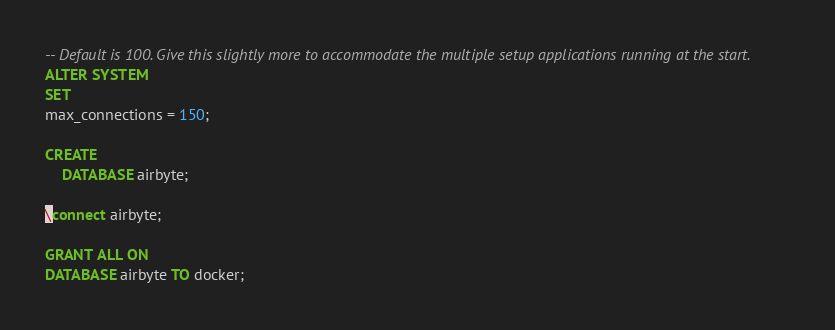<code> <loc_0><loc_0><loc_500><loc_500><_SQL_>-- Default is 100. Give this slightly more to accommodate the multiple setup applications running at the start.
ALTER SYSTEM
SET
max_connections = 150;

CREATE
    DATABASE airbyte;

\connect airbyte;

GRANT ALL ON
DATABASE airbyte TO docker;
</code> 